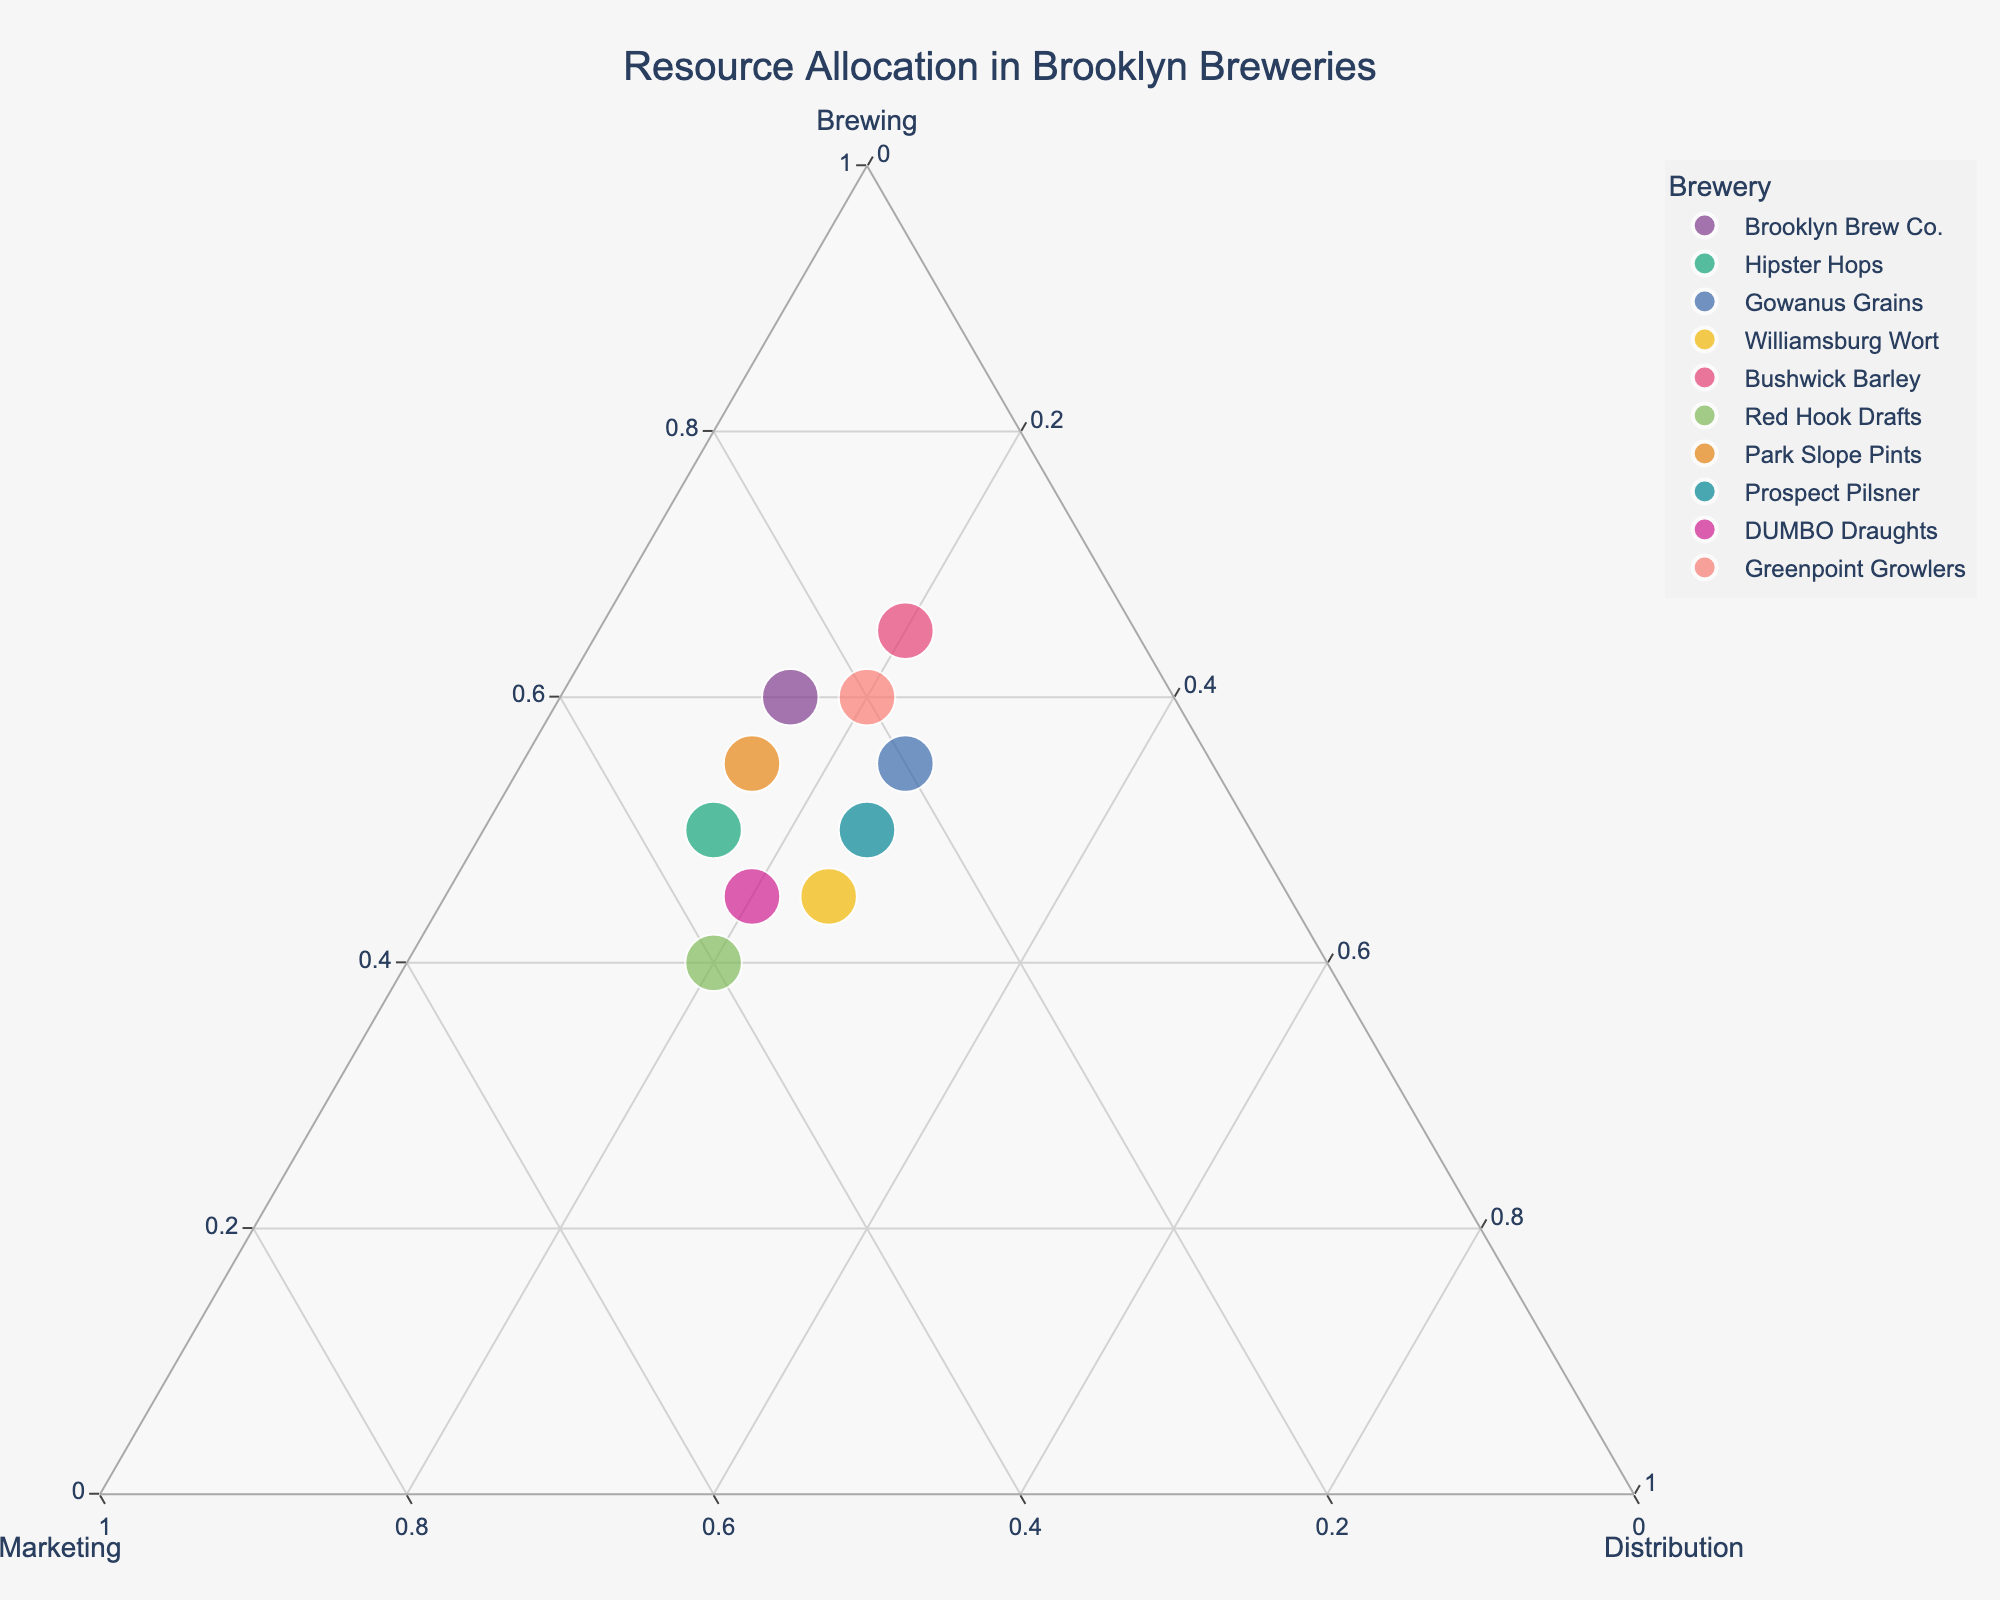What's the title of the figure? The figure has a title element at the top center of the plot. The title is clearly labeled and stated.
Answer: Resource Allocation in Brooklyn Breweries How many breweries are represented in the figure? By counting the individual points marked in the plot or by looking at the legend showing the different breweries, we can determine the total number of breweries.
Answer: 10 Which brewery allocates the largest percentage of resources to Marketing? Look for the point located closest to the Marketing corner (axis b = 1).
Answer: Red Hook Drafts Which two breweries have the same distribution percentage but different brewing and marketing percentages? First, identify points with the same c-axis values. Then compare the a and b-axis values for those points.
Answer: Brooklyn Brew Co. and Greenpoint Growlers What is the approximate percentage allocation to brewing for Park Slope Pints? Locate Park Slope Pints on the ternary plot and read off the value from the Brewing axis (a).
Answer: About 55% Which brewery allocates the smallest percentage to distribution? Look for the point that is furthest from the Distribution corner (axis c = 0).
Answer: Hipster Hops What is the common feature of Bushwick Barley and Brooklyn Brew Co. in terms of resource allocation? Compare the proximity of these breweries' data points to the axes.
Answer: Both allocate the largest percentage to Brewing Which brewery has an almost equal allocation between Marketing and Distribution? Find the point that is near the midpoint of the line connecting the Marketing and Distribution corners.
Answer: Prospect Pilsner How does Bushwick Barley's resource allocation to marketing compare to that of Williamsburg Wort? Compare the distances of the two respective points from the Marketing corner (axis b).
Answer: Bushwick Barley allocates less to Marketing than Williamsburg Wort Which brewery’s allocation is the closest to being evenly split among all three resources? Look for the point near the centroid of the plot (a, b, and c are approximately equal).
Answer: Prospect Pilsner 